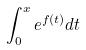<formula> <loc_0><loc_0><loc_500><loc_500>\int _ { 0 } ^ { x } e ^ { f ( t ) } d t</formula> 